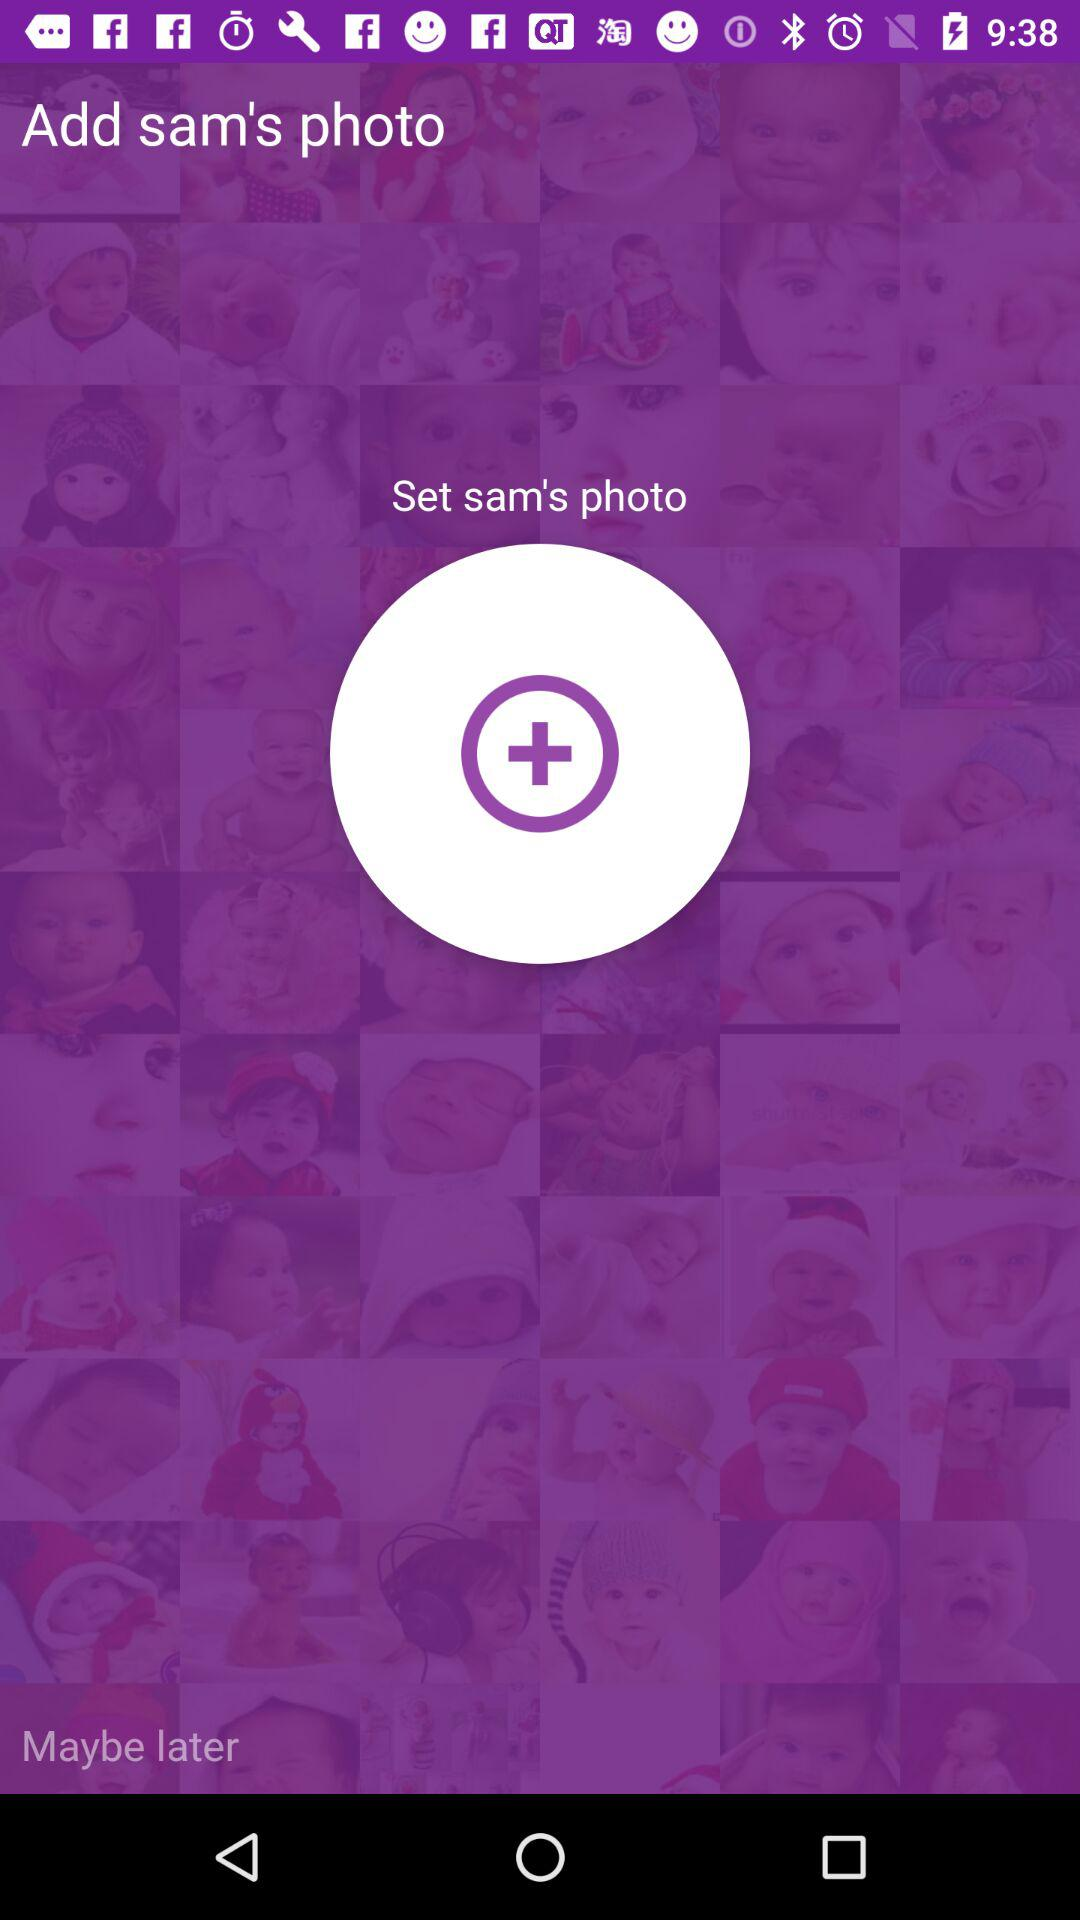How many text elements are there that are not centered?
Answer the question using a single word or phrase. 2 